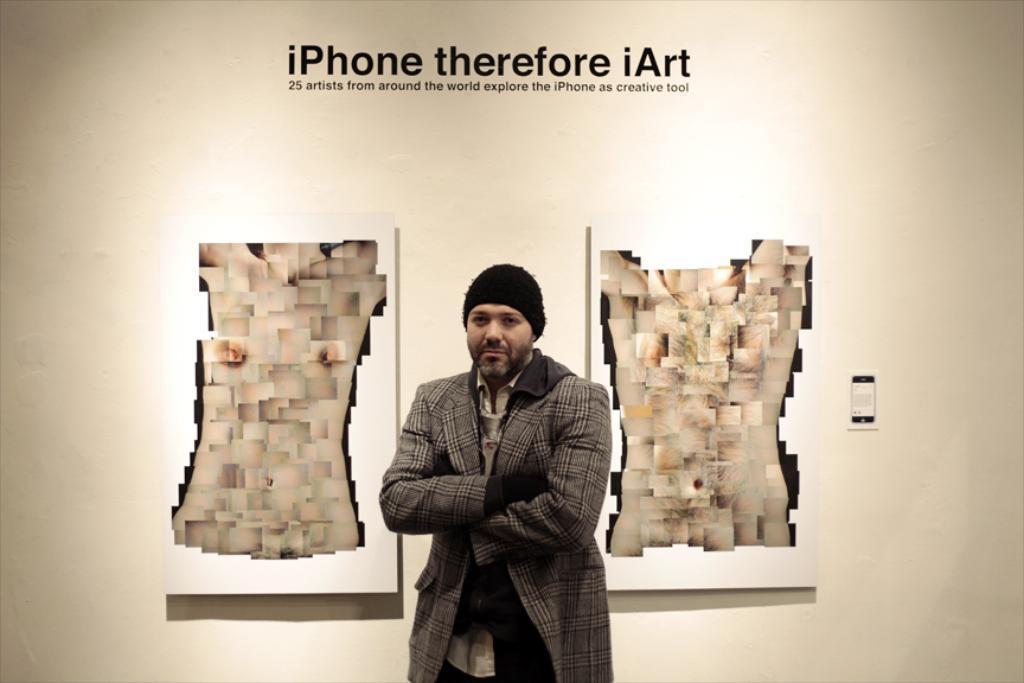Can you describe this image briefly? In the picture we can see a man standing near the wall, he is with blazer and black color cap and folding his hands and on the wall we can see an advertisement of the iPhone. 